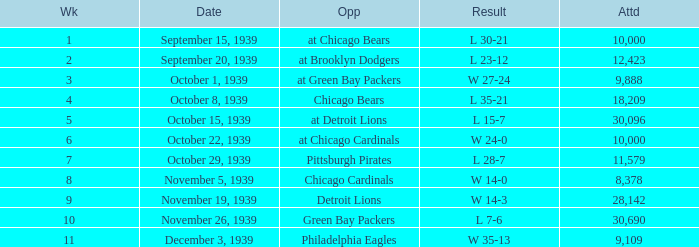Would you be able to parse every entry in this table? {'header': ['Wk', 'Date', 'Opp', 'Result', 'Attd'], 'rows': [['1', 'September 15, 1939', 'at Chicago Bears', 'L 30-21', '10,000'], ['2', 'September 20, 1939', 'at Brooklyn Dodgers', 'L 23-12', '12,423'], ['3', 'October 1, 1939', 'at Green Bay Packers', 'W 27-24', '9,888'], ['4', 'October 8, 1939', 'Chicago Bears', 'L 35-21', '18,209'], ['5', 'October 15, 1939', 'at Detroit Lions', 'L 15-7', '30,096'], ['6', 'October 22, 1939', 'at Chicago Cardinals', 'W 24-0', '10,000'], ['7', 'October 29, 1939', 'Pittsburgh Pirates', 'L 28-7', '11,579'], ['8', 'November 5, 1939', 'Chicago Cardinals', 'W 14-0', '8,378'], ['9', 'November 19, 1939', 'Detroit Lions', 'W 14-3', '28,142'], ['10', 'November 26, 1939', 'Green Bay Packers', 'L 7-6', '30,690'], ['11', 'December 3, 1939', 'Philadelphia Eagles', 'W 35-13', '9,109']]} Which Week has a Result of w 24-0, and an Attendance smaller than 10,000? None. 